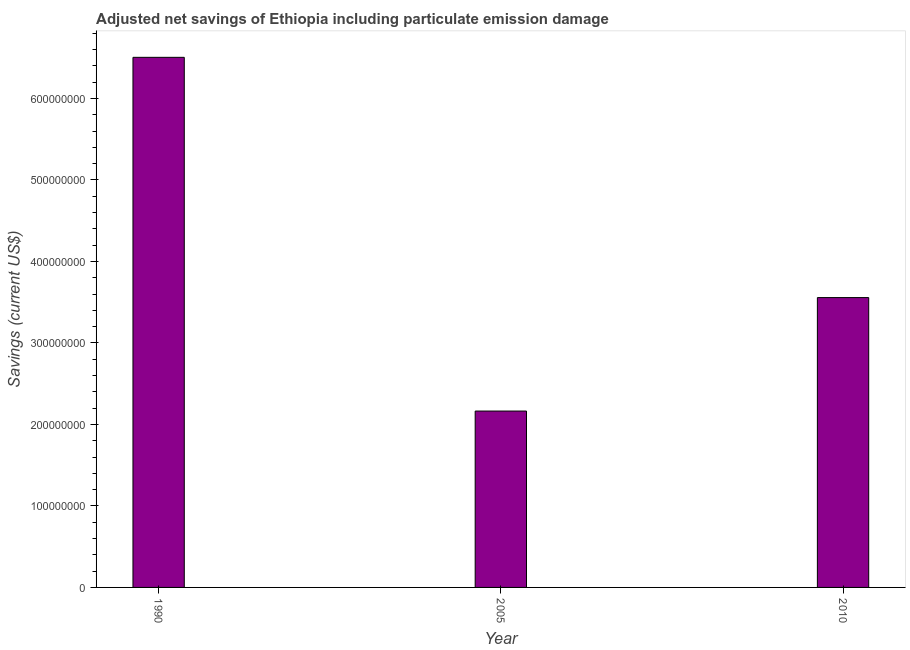Does the graph contain any zero values?
Provide a succinct answer. No. Does the graph contain grids?
Provide a short and direct response. No. What is the title of the graph?
Keep it short and to the point. Adjusted net savings of Ethiopia including particulate emission damage. What is the label or title of the X-axis?
Provide a succinct answer. Year. What is the label or title of the Y-axis?
Offer a very short reply. Savings (current US$). What is the adjusted net savings in 2005?
Provide a succinct answer. 2.16e+08. Across all years, what is the maximum adjusted net savings?
Keep it short and to the point. 6.50e+08. Across all years, what is the minimum adjusted net savings?
Provide a succinct answer. 2.16e+08. In which year was the adjusted net savings minimum?
Make the answer very short. 2005. What is the sum of the adjusted net savings?
Your response must be concise. 1.22e+09. What is the difference between the adjusted net savings in 2005 and 2010?
Offer a terse response. -1.39e+08. What is the average adjusted net savings per year?
Ensure brevity in your answer.  4.07e+08. What is the median adjusted net savings?
Make the answer very short. 3.56e+08. In how many years, is the adjusted net savings greater than 340000000 US$?
Your response must be concise. 2. What is the ratio of the adjusted net savings in 1990 to that in 2010?
Offer a terse response. 1.83. Is the adjusted net savings in 1990 less than that in 2005?
Offer a very short reply. No. What is the difference between the highest and the second highest adjusted net savings?
Make the answer very short. 2.95e+08. What is the difference between the highest and the lowest adjusted net savings?
Provide a short and direct response. 4.34e+08. In how many years, is the adjusted net savings greater than the average adjusted net savings taken over all years?
Ensure brevity in your answer.  1. How many bars are there?
Offer a very short reply. 3. Are the values on the major ticks of Y-axis written in scientific E-notation?
Your answer should be compact. No. What is the Savings (current US$) in 1990?
Keep it short and to the point. 6.50e+08. What is the Savings (current US$) of 2005?
Your answer should be compact. 2.16e+08. What is the Savings (current US$) of 2010?
Your answer should be compact. 3.56e+08. What is the difference between the Savings (current US$) in 1990 and 2005?
Your answer should be compact. 4.34e+08. What is the difference between the Savings (current US$) in 1990 and 2010?
Make the answer very short. 2.95e+08. What is the difference between the Savings (current US$) in 2005 and 2010?
Make the answer very short. -1.39e+08. What is the ratio of the Savings (current US$) in 1990 to that in 2005?
Offer a very short reply. 3. What is the ratio of the Savings (current US$) in 1990 to that in 2010?
Provide a succinct answer. 1.83. What is the ratio of the Savings (current US$) in 2005 to that in 2010?
Your answer should be very brief. 0.61. 